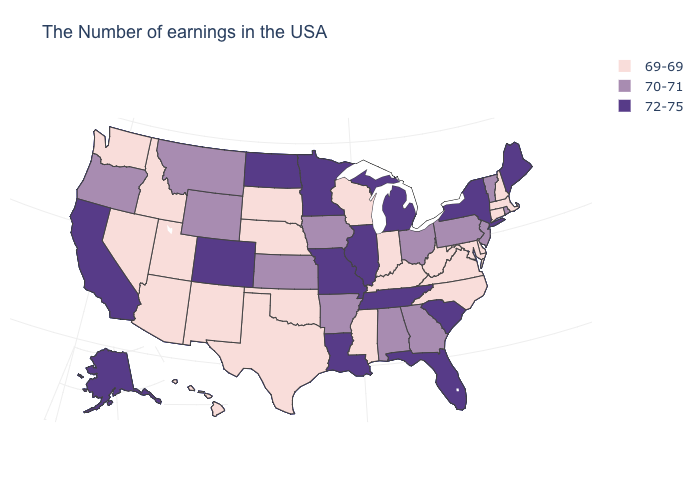Name the states that have a value in the range 72-75?
Keep it brief. Maine, New York, South Carolina, Florida, Michigan, Tennessee, Illinois, Louisiana, Missouri, Minnesota, North Dakota, Colorado, California, Alaska. Is the legend a continuous bar?
Short answer required. No. What is the value of Pennsylvania?
Write a very short answer. 70-71. Among the states that border Idaho , does Wyoming have the lowest value?
Answer briefly. No. What is the value of Iowa?
Concise answer only. 70-71. Name the states that have a value in the range 72-75?
Concise answer only. Maine, New York, South Carolina, Florida, Michigan, Tennessee, Illinois, Louisiana, Missouri, Minnesota, North Dakota, Colorado, California, Alaska. Which states have the lowest value in the USA?
Give a very brief answer. Massachusetts, New Hampshire, Connecticut, Delaware, Maryland, Virginia, North Carolina, West Virginia, Kentucky, Indiana, Wisconsin, Mississippi, Nebraska, Oklahoma, Texas, South Dakota, New Mexico, Utah, Arizona, Idaho, Nevada, Washington, Hawaii. Name the states that have a value in the range 69-69?
Give a very brief answer. Massachusetts, New Hampshire, Connecticut, Delaware, Maryland, Virginia, North Carolina, West Virginia, Kentucky, Indiana, Wisconsin, Mississippi, Nebraska, Oklahoma, Texas, South Dakota, New Mexico, Utah, Arizona, Idaho, Nevada, Washington, Hawaii. What is the highest value in the USA?
Be succinct. 72-75. Is the legend a continuous bar?
Concise answer only. No. What is the highest value in states that border Michigan?
Keep it brief. 70-71. Among the states that border Connecticut , does New York have the highest value?
Concise answer only. Yes. Which states have the lowest value in the USA?
Short answer required. Massachusetts, New Hampshire, Connecticut, Delaware, Maryland, Virginia, North Carolina, West Virginia, Kentucky, Indiana, Wisconsin, Mississippi, Nebraska, Oklahoma, Texas, South Dakota, New Mexico, Utah, Arizona, Idaho, Nevada, Washington, Hawaii. What is the highest value in the USA?
Be succinct. 72-75. Among the states that border Missouri , does Kansas have the lowest value?
Answer briefly. No. 